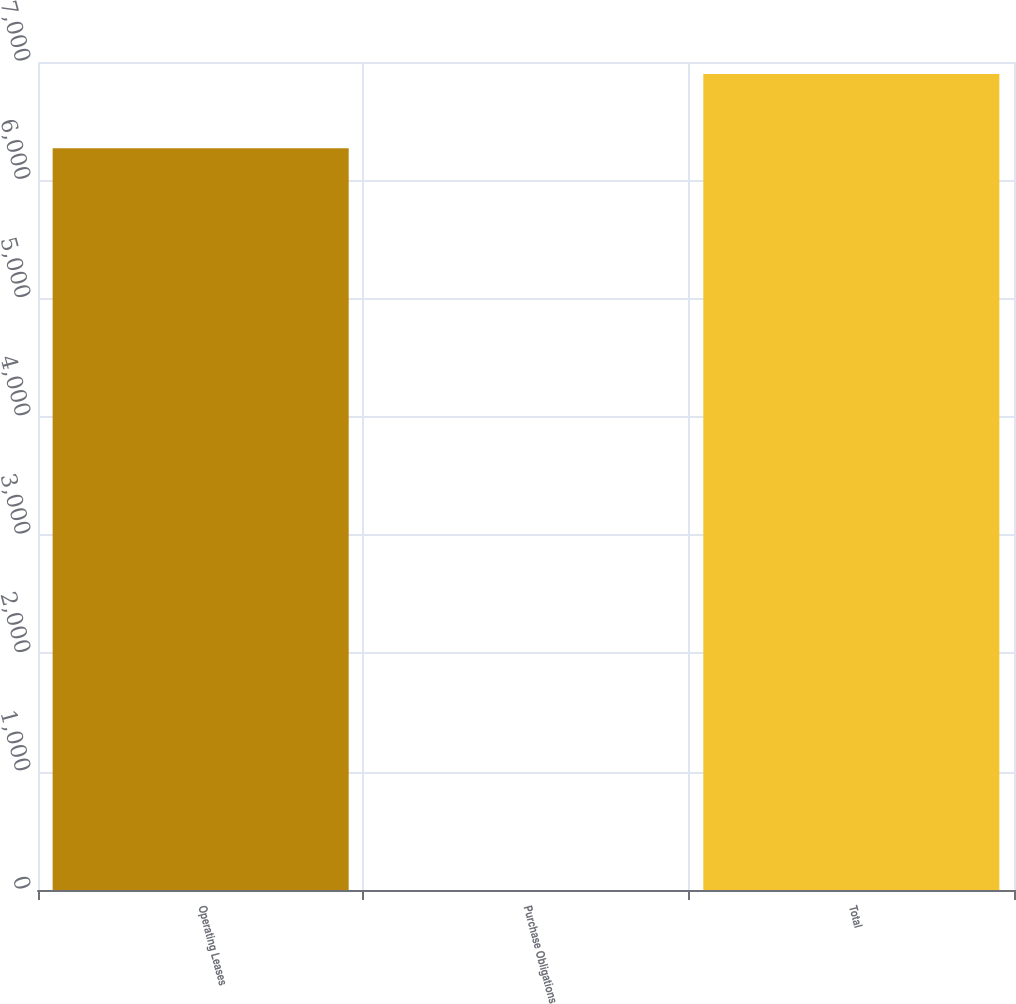<chart> <loc_0><loc_0><loc_500><loc_500><bar_chart><fcel>Operating Leases<fcel>Purchase Obligations<fcel>Total<nl><fcel>6271<fcel>0.38<fcel>6898.06<nl></chart> 